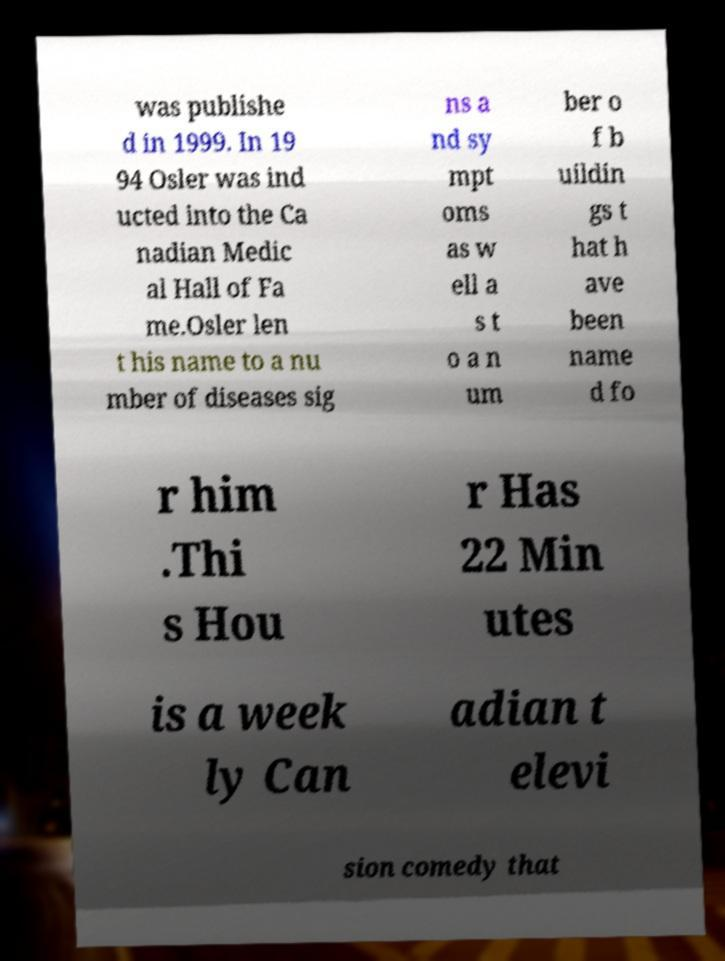What messages or text are displayed in this image? I need them in a readable, typed format. was publishe d in 1999. In 19 94 Osler was ind ucted into the Ca nadian Medic al Hall of Fa me.Osler len t his name to a nu mber of diseases sig ns a nd sy mpt oms as w ell a s t o a n um ber o f b uildin gs t hat h ave been name d fo r him .Thi s Hou r Has 22 Min utes is a week ly Can adian t elevi sion comedy that 